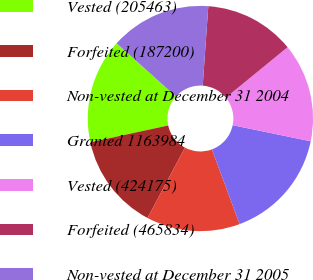Convert chart to OTSL. <chart><loc_0><loc_0><loc_500><loc_500><pie_chart><fcel>Vested (205463)<fcel>Forfeited (187200)<fcel>Non-vested at December 31 2004<fcel>Granted 1163984<fcel>Vested (424175)<fcel>Forfeited (465834)<fcel>Non-vested at December 31 2005<nl><fcel>15.03%<fcel>13.84%<fcel>13.44%<fcel>16.1%<fcel>14.15%<fcel>12.97%<fcel>14.47%<nl></chart> 